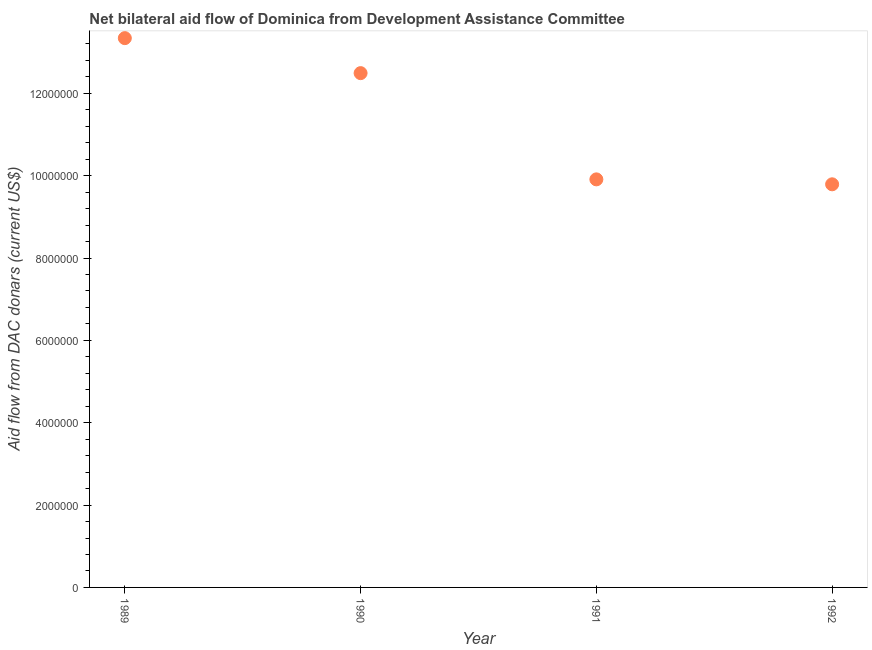What is the net bilateral aid flows from dac donors in 1990?
Offer a very short reply. 1.25e+07. Across all years, what is the maximum net bilateral aid flows from dac donors?
Your answer should be compact. 1.33e+07. Across all years, what is the minimum net bilateral aid flows from dac donors?
Keep it short and to the point. 9.79e+06. In which year was the net bilateral aid flows from dac donors maximum?
Make the answer very short. 1989. What is the sum of the net bilateral aid flows from dac donors?
Ensure brevity in your answer.  4.55e+07. What is the difference between the net bilateral aid flows from dac donors in 1989 and 1991?
Your answer should be compact. 3.43e+06. What is the average net bilateral aid flows from dac donors per year?
Make the answer very short. 1.14e+07. What is the median net bilateral aid flows from dac donors?
Your answer should be very brief. 1.12e+07. What is the ratio of the net bilateral aid flows from dac donors in 1991 to that in 1992?
Offer a terse response. 1.01. Is the difference between the net bilateral aid flows from dac donors in 1991 and 1992 greater than the difference between any two years?
Give a very brief answer. No. What is the difference between the highest and the second highest net bilateral aid flows from dac donors?
Provide a succinct answer. 8.50e+05. Is the sum of the net bilateral aid flows from dac donors in 1990 and 1991 greater than the maximum net bilateral aid flows from dac donors across all years?
Your response must be concise. Yes. What is the difference between the highest and the lowest net bilateral aid flows from dac donors?
Give a very brief answer. 3.55e+06. Does the net bilateral aid flows from dac donors monotonically increase over the years?
Offer a terse response. No. How many dotlines are there?
Your answer should be compact. 1. How many years are there in the graph?
Ensure brevity in your answer.  4. Does the graph contain any zero values?
Provide a succinct answer. No. Does the graph contain grids?
Provide a succinct answer. No. What is the title of the graph?
Offer a very short reply. Net bilateral aid flow of Dominica from Development Assistance Committee. What is the label or title of the X-axis?
Your answer should be very brief. Year. What is the label or title of the Y-axis?
Offer a very short reply. Aid flow from DAC donars (current US$). What is the Aid flow from DAC donars (current US$) in 1989?
Provide a succinct answer. 1.33e+07. What is the Aid flow from DAC donars (current US$) in 1990?
Make the answer very short. 1.25e+07. What is the Aid flow from DAC donars (current US$) in 1991?
Your answer should be compact. 9.91e+06. What is the Aid flow from DAC donars (current US$) in 1992?
Make the answer very short. 9.79e+06. What is the difference between the Aid flow from DAC donars (current US$) in 1989 and 1990?
Offer a very short reply. 8.50e+05. What is the difference between the Aid flow from DAC donars (current US$) in 1989 and 1991?
Make the answer very short. 3.43e+06. What is the difference between the Aid flow from DAC donars (current US$) in 1989 and 1992?
Give a very brief answer. 3.55e+06. What is the difference between the Aid flow from DAC donars (current US$) in 1990 and 1991?
Ensure brevity in your answer.  2.58e+06. What is the difference between the Aid flow from DAC donars (current US$) in 1990 and 1992?
Offer a terse response. 2.70e+06. What is the ratio of the Aid flow from DAC donars (current US$) in 1989 to that in 1990?
Your response must be concise. 1.07. What is the ratio of the Aid flow from DAC donars (current US$) in 1989 to that in 1991?
Ensure brevity in your answer.  1.35. What is the ratio of the Aid flow from DAC donars (current US$) in 1989 to that in 1992?
Provide a succinct answer. 1.36. What is the ratio of the Aid flow from DAC donars (current US$) in 1990 to that in 1991?
Give a very brief answer. 1.26. What is the ratio of the Aid flow from DAC donars (current US$) in 1990 to that in 1992?
Keep it short and to the point. 1.28. 